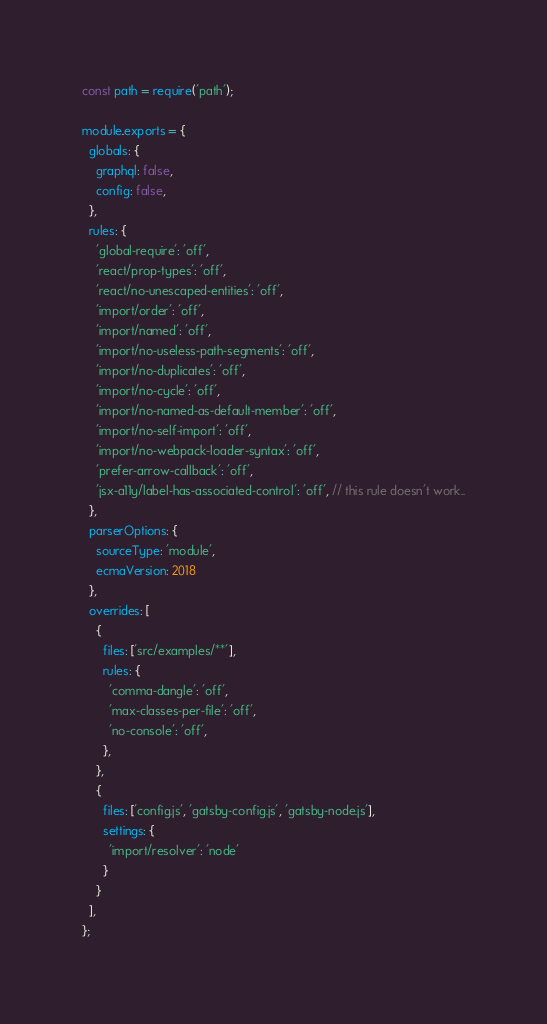Convert code to text. <code><loc_0><loc_0><loc_500><loc_500><_JavaScript_>const path = require('path');

module.exports = {
  globals: {
    graphql: false,
    config: false,
  },
  rules: {
    'global-require': 'off',
    'react/prop-types': 'off',
    'react/no-unescaped-entities': 'off',
    'import/order': 'off',
    'import/named': 'off',
    'import/no-useless-path-segments': 'off',
    'import/no-duplicates': 'off',
    'import/no-cycle': 'off',
    'import/no-named-as-default-member': 'off',
    'import/no-self-import': 'off',
    'import/no-webpack-loader-syntax': 'off',
    'prefer-arrow-callback': 'off',
    'jsx-a11y/label-has-associated-control': 'off', // this rule doesn't work..
  },
  parserOptions: { 
    sourceType: 'module',
    ecmaVersion: 2018
  },
  overrides: [
    {
      files: ['src/examples/**'],
      rules: {
        'comma-dangle': 'off',
        'max-classes-per-file': 'off',
        'no-console': 'off',
      },
    },
    {
      files: ['config.js', 'gatsby-config.js', 'gatsby-node.js'],
      settings: {
        'import/resolver': 'node'
      }
    }
  ],
};
</code> 